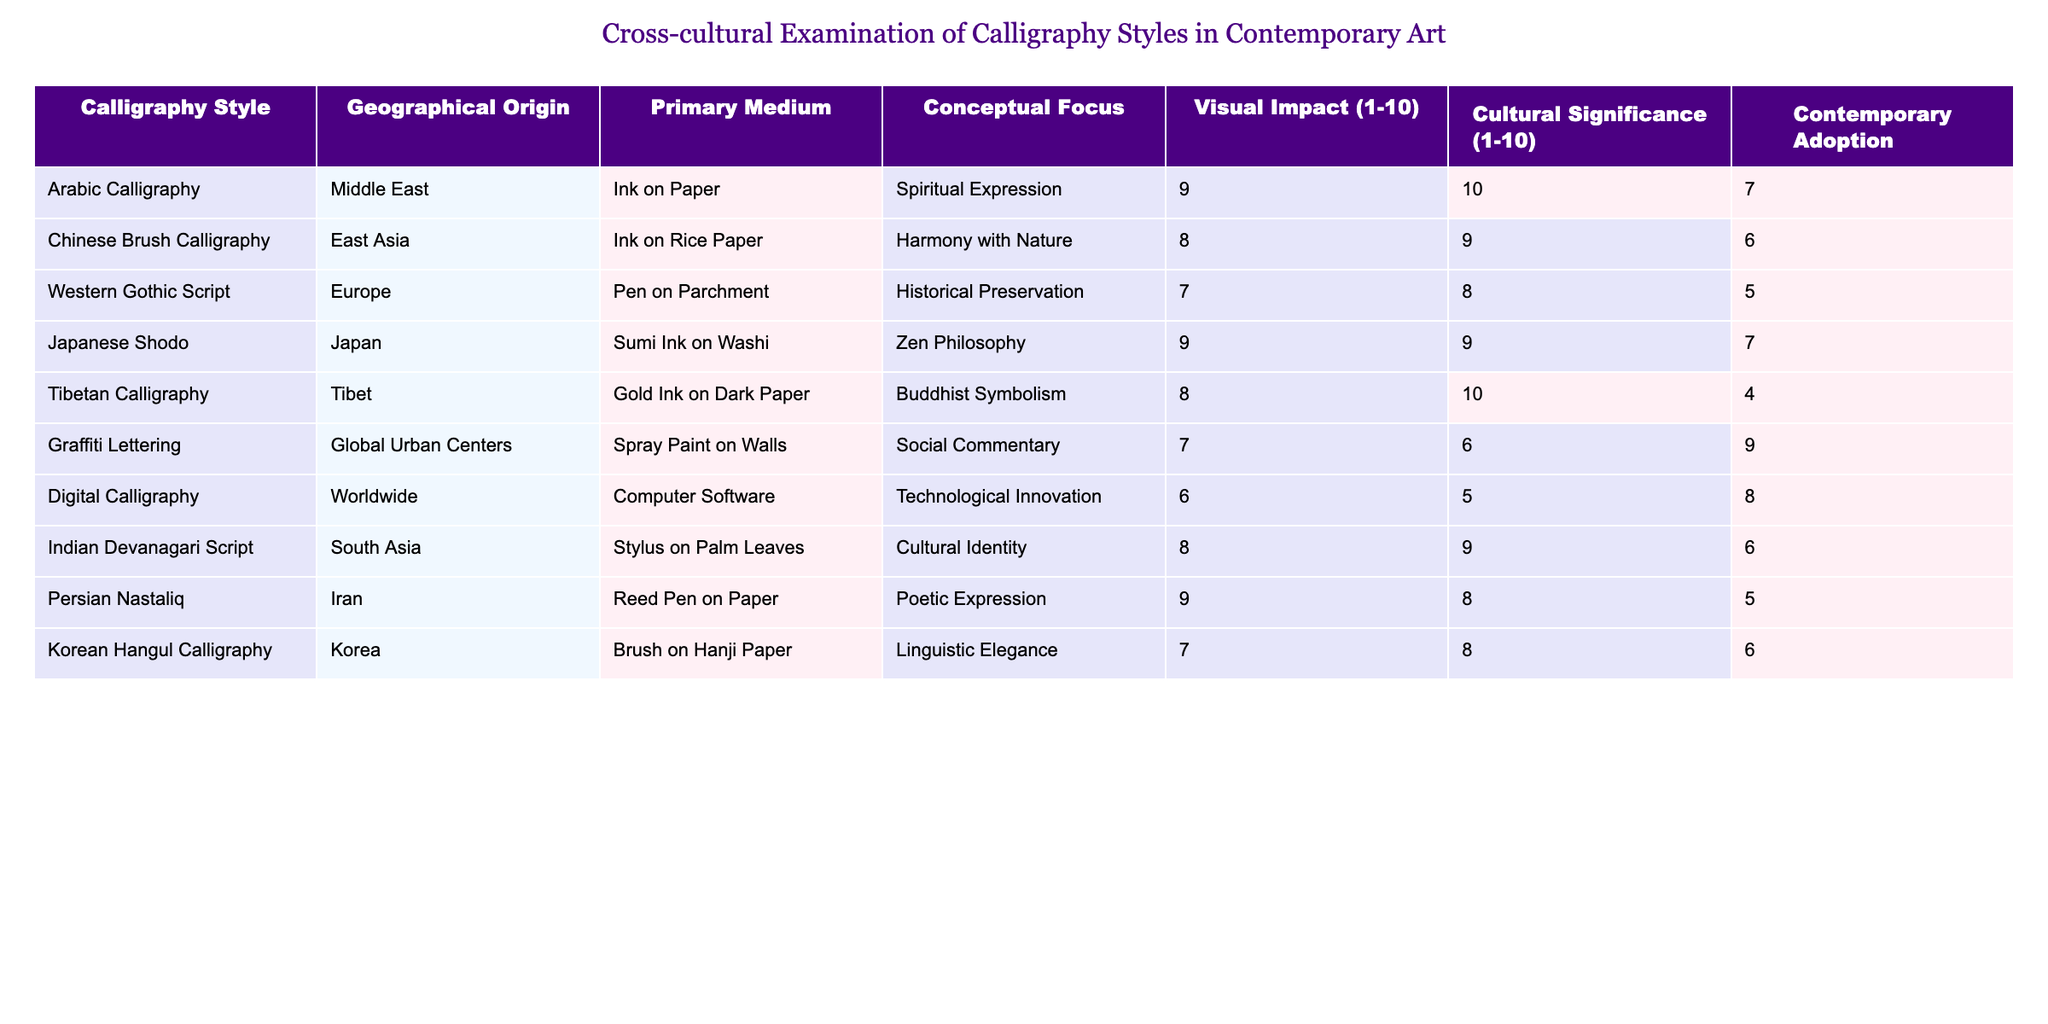What is the primary medium used in Arabic Calligraphy? The table lists the primary medium of each calligraphy style, and for Arabic Calligraphy, it is specified as "Ink on Paper."
Answer: Ink on Paper Which calligraphy style has the highest Cultural Significance rating? By examining the Cultural Significance ratings in the table, Tibetan Calligraphy has a rating of 10, which is the highest compared to others.
Answer: Tibetan Calligraphy What is the average Visual Impact rating of all calligraphy styles listed? To find the average Visual Impact, we sum the values: (9 + 8 + 7 + 9 + 8 + 7 + 6 + 8 + 9 + 7) = 78, and divide by the number of styles (10), resulting in 78/10 = 7.8.
Answer: 7.8 Is Graffiti Lettering more popular in contemporary art compared to Tibetan Calligraphy? Comparing their contemporary adoption ratings, Graffiti Lettering has a rating of 9, while Tibetan Calligraphy has 4. Thus, Graffiti Lettering is more popular in contemporary art.
Answer: Yes What is the difference in Visual Impact ratings between Chinese Brush Calligraphy and Digital Calligraphy? The Visual Impact rating for Chinese Brush Calligraphy is 8 and for Digital Calligraphy is 6. The difference is 8 - 6 = 2.
Answer: 2 How many calligraphy styles have a Cultural Significance rating of 9 or above? From the table, there are four styles with a rating of 9 or above: Arabic Calligraphy (10), Chinese Brush Calligraphy (9), Japanese Shodo (9), and Indian Devanagari Script (9). So, the count is 4.
Answer: 4 What is the ranking order of calligraphy styles based on their Visual Impact? By reviewing the Visual Impact ratings, the ranking from highest to lowest is: Arabic Calligraphy, Japanese Shodo, Chinese Brush Calligraphy, Tibetan Calligraphy, Graffiti Lettering, Western Gothic Script, Indian Devanagari Script, Korean Hangul Calligraphy, Digital Calligraphy, Persian Nastaliq.
Answer: Arabic, Japanese, Chinese, Tibetan, Graffiti, Western Gothic, Indian, Korean, Digital, Persian Which calligraphy style has the lowest Contemporary Adoption? The table shows that Tibetan Calligraphy has a Contemporary Adoption rating of 4, which is the lowest among all the styles listed.
Answer: Tibetan Calligraphy What is the overall average Cultural Significance rating for the calligraphy styles examined? Summing the Cultural Significance ratings gives us: (10 + 9 + 8 + 9 + 10 + 6 + 5 + 9 + 8 + 8) = 82, and dividing by 10 results in an average Cultural Significance of 8.2.
Answer: 8.2 Is there a calligraphy style that scores 7 in both Visual Impact and Cultural Significance? Evaluating the ratings, Graffiti Lettering has a Visual Impact of 7 and a Cultural Significance of 6, while other styles do not match being 7 in both. Therefore, there is no style that fits this criterion.
Answer: No 